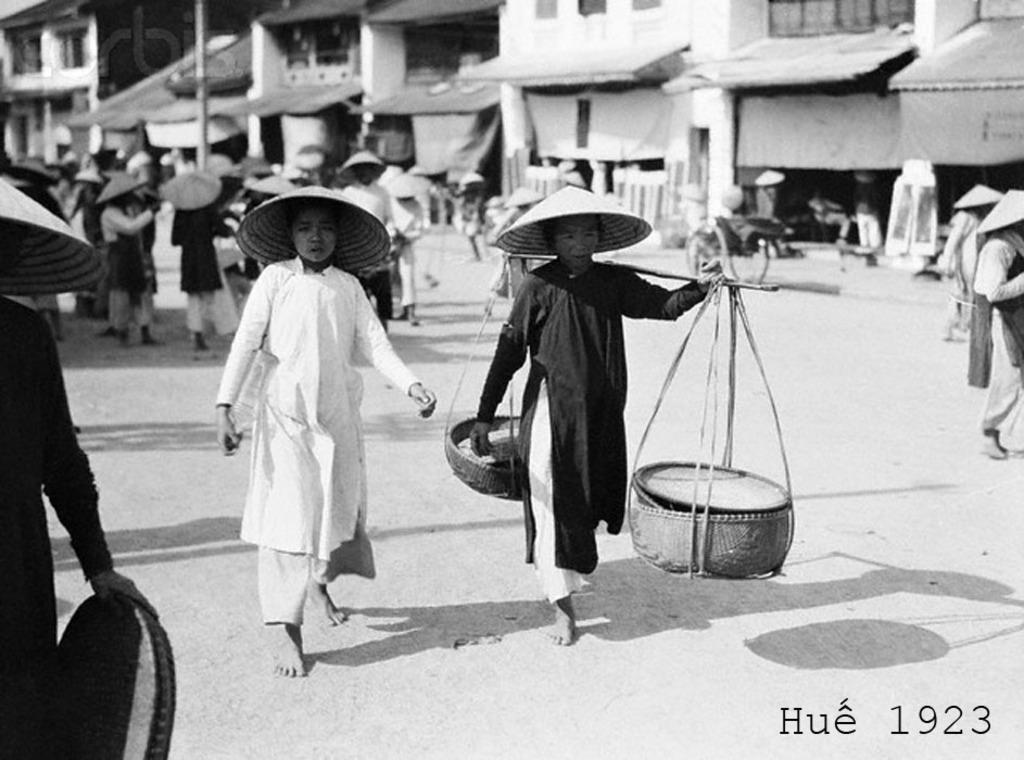What is the person in the image holding? The person in the image is holding baskets. Can you describe the clothing of the other people in the image? The other people in the image are wearing hats. What type of structures can be seen in the background of the image? There are buildings visible in the image. How many trousers are hanging in the cellar in the image? There is no cellar or trousers present in the image. What is the elbow of the person holding baskets doing in the image? The elbow of the person holding baskets is not mentioned in the image, so it cannot be determined what it is doing. 